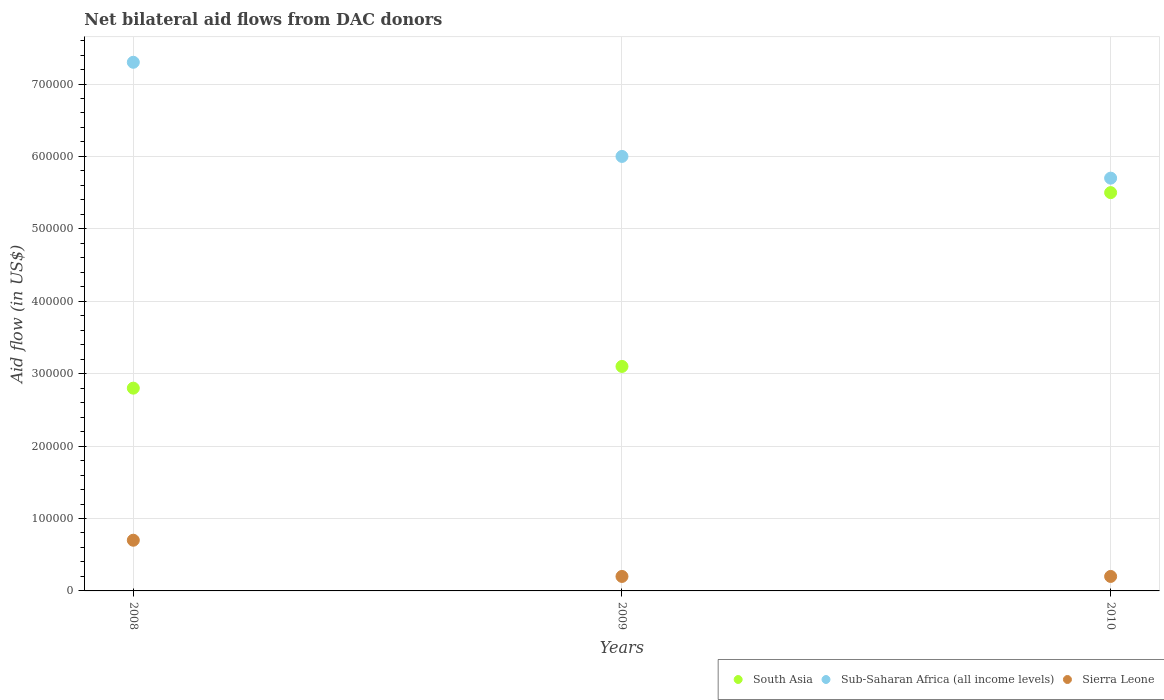How many different coloured dotlines are there?
Ensure brevity in your answer.  3. Is the number of dotlines equal to the number of legend labels?
Your answer should be very brief. Yes. What is the net bilateral aid flow in Sub-Saharan Africa (all income levels) in 2009?
Your response must be concise. 6.00e+05. Across all years, what is the minimum net bilateral aid flow in South Asia?
Give a very brief answer. 2.80e+05. In which year was the net bilateral aid flow in South Asia maximum?
Make the answer very short. 2010. In which year was the net bilateral aid flow in Sub-Saharan Africa (all income levels) minimum?
Give a very brief answer. 2010. What is the total net bilateral aid flow in Sub-Saharan Africa (all income levels) in the graph?
Make the answer very short. 1.90e+06. What is the difference between the net bilateral aid flow in South Asia in 2008 and that in 2010?
Give a very brief answer. -2.70e+05. What is the difference between the net bilateral aid flow in South Asia in 2010 and the net bilateral aid flow in Sub-Saharan Africa (all income levels) in 2008?
Make the answer very short. -1.80e+05. In the year 2010, what is the difference between the net bilateral aid flow in Sub-Saharan Africa (all income levels) and net bilateral aid flow in South Asia?
Offer a very short reply. 2.00e+04. What is the ratio of the net bilateral aid flow in South Asia in 2009 to that in 2010?
Ensure brevity in your answer.  0.56. What is the difference between the highest and the second highest net bilateral aid flow in Sub-Saharan Africa (all income levels)?
Your answer should be compact. 1.30e+05. What is the difference between the highest and the lowest net bilateral aid flow in South Asia?
Your response must be concise. 2.70e+05. Is the sum of the net bilateral aid flow in South Asia in 2008 and 2009 greater than the maximum net bilateral aid flow in Sierra Leone across all years?
Offer a very short reply. Yes. Is it the case that in every year, the sum of the net bilateral aid flow in South Asia and net bilateral aid flow in Sierra Leone  is greater than the net bilateral aid flow in Sub-Saharan Africa (all income levels)?
Provide a succinct answer. No. Does the net bilateral aid flow in South Asia monotonically increase over the years?
Give a very brief answer. Yes. Is the net bilateral aid flow in South Asia strictly greater than the net bilateral aid flow in Sub-Saharan Africa (all income levels) over the years?
Offer a terse response. No. How many dotlines are there?
Your answer should be compact. 3. Are the values on the major ticks of Y-axis written in scientific E-notation?
Offer a terse response. No. Does the graph contain grids?
Provide a succinct answer. Yes. How many legend labels are there?
Your response must be concise. 3. How are the legend labels stacked?
Make the answer very short. Horizontal. What is the title of the graph?
Your answer should be compact. Net bilateral aid flows from DAC donors. What is the label or title of the X-axis?
Provide a short and direct response. Years. What is the label or title of the Y-axis?
Give a very brief answer. Aid flow (in US$). What is the Aid flow (in US$) of Sub-Saharan Africa (all income levels) in 2008?
Offer a terse response. 7.30e+05. What is the Aid flow (in US$) of Sierra Leone in 2009?
Provide a succinct answer. 2.00e+04. What is the Aid flow (in US$) in Sub-Saharan Africa (all income levels) in 2010?
Your answer should be very brief. 5.70e+05. What is the Aid flow (in US$) in Sierra Leone in 2010?
Make the answer very short. 2.00e+04. Across all years, what is the maximum Aid flow (in US$) in South Asia?
Offer a terse response. 5.50e+05. Across all years, what is the maximum Aid flow (in US$) in Sub-Saharan Africa (all income levels)?
Keep it short and to the point. 7.30e+05. Across all years, what is the minimum Aid flow (in US$) of South Asia?
Offer a very short reply. 2.80e+05. Across all years, what is the minimum Aid flow (in US$) of Sub-Saharan Africa (all income levels)?
Keep it short and to the point. 5.70e+05. What is the total Aid flow (in US$) of South Asia in the graph?
Give a very brief answer. 1.14e+06. What is the total Aid flow (in US$) of Sub-Saharan Africa (all income levels) in the graph?
Keep it short and to the point. 1.90e+06. What is the total Aid flow (in US$) in Sierra Leone in the graph?
Provide a succinct answer. 1.10e+05. What is the difference between the Aid flow (in US$) of South Asia in 2008 and that in 2009?
Your answer should be compact. -3.00e+04. What is the difference between the Aid flow (in US$) in Sierra Leone in 2008 and that in 2009?
Provide a succinct answer. 5.00e+04. What is the difference between the Aid flow (in US$) in South Asia in 2009 and that in 2010?
Make the answer very short. -2.40e+05. What is the difference between the Aid flow (in US$) in South Asia in 2008 and the Aid flow (in US$) in Sub-Saharan Africa (all income levels) in 2009?
Your response must be concise. -3.20e+05. What is the difference between the Aid flow (in US$) of Sub-Saharan Africa (all income levels) in 2008 and the Aid flow (in US$) of Sierra Leone in 2009?
Give a very brief answer. 7.10e+05. What is the difference between the Aid flow (in US$) of South Asia in 2008 and the Aid flow (in US$) of Sub-Saharan Africa (all income levels) in 2010?
Ensure brevity in your answer.  -2.90e+05. What is the difference between the Aid flow (in US$) in South Asia in 2008 and the Aid flow (in US$) in Sierra Leone in 2010?
Your answer should be very brief. 2.60e+05. What is the difference between the Aid flow (in US$) in Sub-Saharan Africa (all income levels) in 2008 and the Aid flow (in US$) in Sierra Leone in 2010?
Your response must be concise. 7.10e+05. What is the difference between the Aid flow (in US$) in South Asia in 2009 and the Aid flow (in US$) in Sierra Leone in 2010?
Offer a terse response. 2.90e+05. What is the difference between the Aid flow (in US$) in Sub-Saharan Africa (all income levels) in 2009 and the Aid flow (in US$) in Sierra Leone in 2010?
Your answer should be very brief. 5.80e+05. What is the average Aid flow (in US$) of Sub-Saharan Africa (all income levels) per year?
Provide a succinct answer. 6.33e+05. What is the average Aid flow (in US$) of Sierra Leone per year?
Your response must be concise. 3.67e+04. In the year 2008, what is the difference between the Aid flow (in US$) of South Asia and Aid flow (in US$) of Sub-Saharan Africa (all income levels)?
Offer a terse response. -4.50e+05. In the year 2009, what is the difference between the Aid flow (in US$) of Sub-Saharan Africa (all income levels) and Aid flow (in US$) of Sierra Leone?
Your answer should be compact. 5.80e+05. In the year 2010, what is the difference between the Aid flow (in US$) of South Asia and Aid flow (in US$) of Sub-Saharan Africa (all income levels)?
Give a very brief answer. -2.00e+04. In the year 2010, what is the difference between the Aid flow (in US$) of South Asia and Aid flow (in US$) of Sierra Leone?
Ensure brevity in your answer.  5.30e+05. What is the ratio of the Aid flow (in US$) in South Asia in 2008 to that in 2009?
Your answer should be compact. 0.9. What is the ratio of the Aid flow (in US$) in Sub-Saharan Africa (all income levels) in 2008 to that in 2009?
Make the answer very short. 1.22. What is the ratio of the Aid flow (in US$) in South Asia in 2008 to that in 2010?
Provide a succinct answer. 0.51. What is the ratio of the Aid flow (in US$) in Sub-Saharan Africa (all income levels) in 2008 to that in 2010?
Provide a succinct answer. 1.28. What is the ratio of the Aid flow (in US$) of South Asia in 2009 to that in 2010?
Your answer should be compact. 0.56. What is the ratio of the Aid flow (in US$) of Sub-Saharan Africa (all income levels) in 2009 to that in 2010?
Provide a succinct answer. 1.05. What is the difference between the highest and the lowest Aid flow (in US$) of Sub-Saharan Africa (all income levels)?
Your answer should be very brief. 1.60e+05. What is the difference between the highest and the lowest Aid flow (in US$) in Sierra Leone?
Provide a short and direct response. 5.00e+04. 